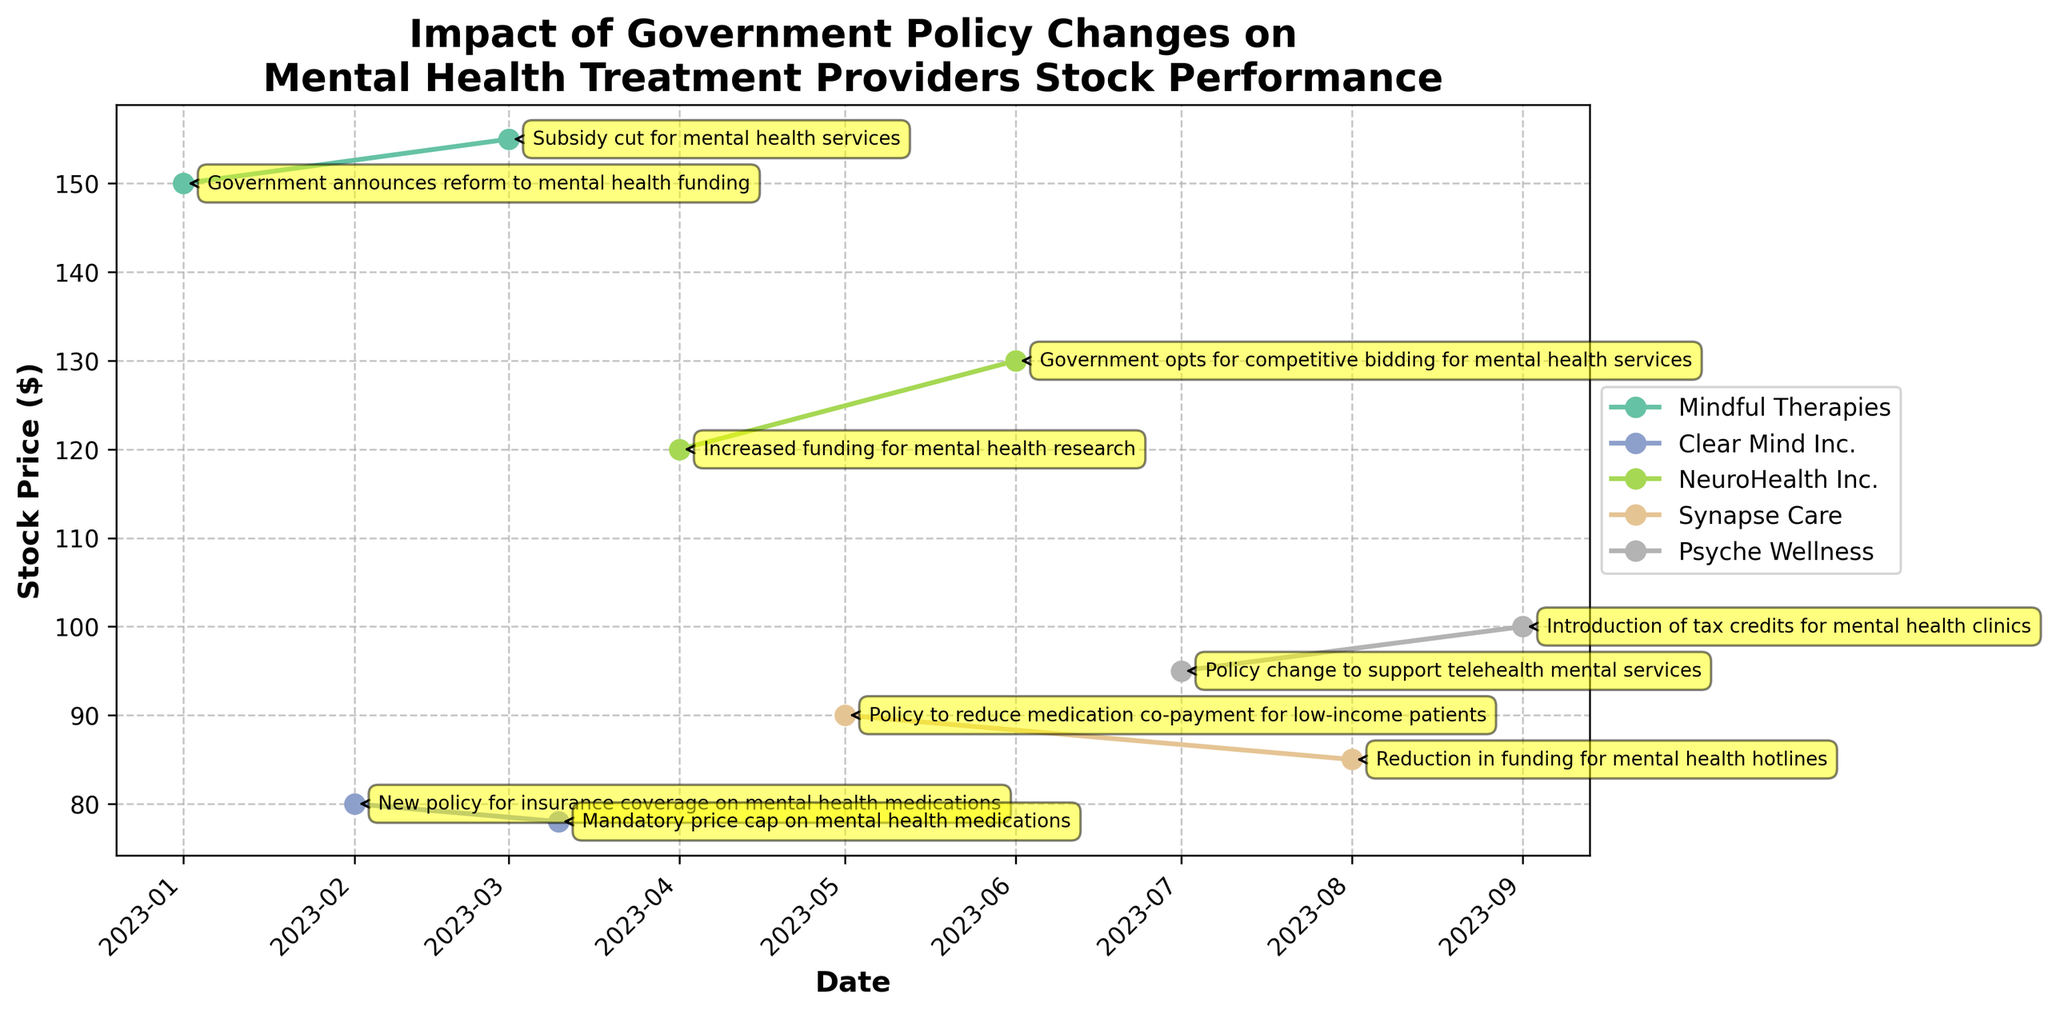What is the title of the figure? The title is displayed at the top of the figure.
Answer: Impact of Government Policy Changes on Mental Health Treatment Providers Stock Performance What is the stock price of Clear Mind Inc. on 2023-03-10? Look for Clear Mind Inc. in the annotation for 2023-03-10 and read the stock price next to it.
Answer: 78 Which company experienced a policy change that resulted in the highest stock price? Identify the company with the highest stock price by looking at the peaks in the plot lines.
Answer: Mindful Therapies How many companies are tracked in this figure? Count the number of unique colored lines representing different companies in the plot.
Answer: 5 Which event had a negative impact on Mindful Therapies' stock price? Check the annotations along the Mindful Therapies line for events marked with a negative impact.
Answer: Subsidy cut for mental health services Which company had a positive impact on the stock price on 2023-07-01, and what was the policy change? Look at the annotation for 2023-07-01 and identify the company and policy.
Answer: Psyche Wellness; Policy change to support telehealth mental services Comparing NeuroHealth Inc. and Synapse Care, which company saw a greater increase in stock price from their respective positive policy changes? Calculate the increase in stock price for NeuroHealth Inc. and Synapse Care from their positive policy changes and compare.  
- NeuroHealth: Increased funding for mental health research (120 to 130, +10)
- Synapse Care: Policy to reduce medication co-payment for low-income patients (90 to 85, -5)  
So, the greater increase is for NeuroHealth Inc.
Answer: NeuroHealth Inc What was the impact on the stock price of Synapse Care due to the reduction in funding for mental health hotlines? Check the difference in the stock price of Synapse Care before and after the event on 2023-08-01.
Answer: 90 to 85; decreased by 5 Which company had the lowest stock price at any point in time, and what was that price? Identify the lowest point on the plot and check the company and stock price.
Answer: Clear Mind Inc., 78 Which policy changes resulted in the same stock price change for more than one company? Compare the annotations and stock prices for each company to find matching stock price changes due to different policies.  
- Both Mindful Therapies and Clear Mind Inc. had negative impacts, 
- Mindful Therapies' subsidy cut (155 to 150, -5) 
- Clear Mind Inc.'s price cap on medications (80 to 78, -2)  
So different in impact. 
No exact matching stock price changes.
Answer: No exact matching changes 